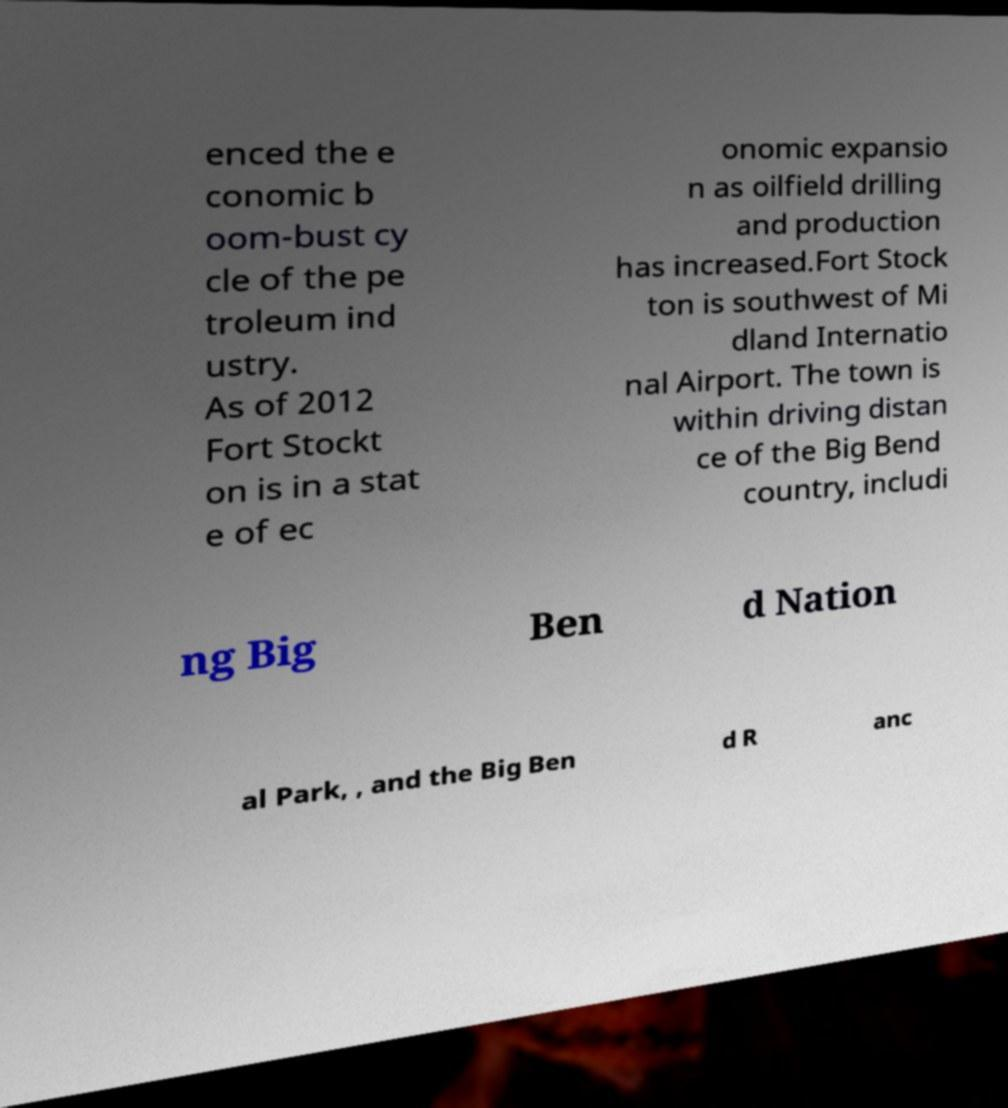I need the written content from this picture converted into text. Can you do that? enced the e conomic b oom-bust cy cle of the pe troleum ind ustry. As of 2012 Fort Stockt on is in a stat e of ec onomic expansio n as oilfield drilling and production has increased.Fort Stock ton is southwest of Mi dland Internatio nal Airport. The town is within driving distan ce of the Big Bend country, includi ng Big Ben d Nation al Park, , and the Big Ben d R anc 